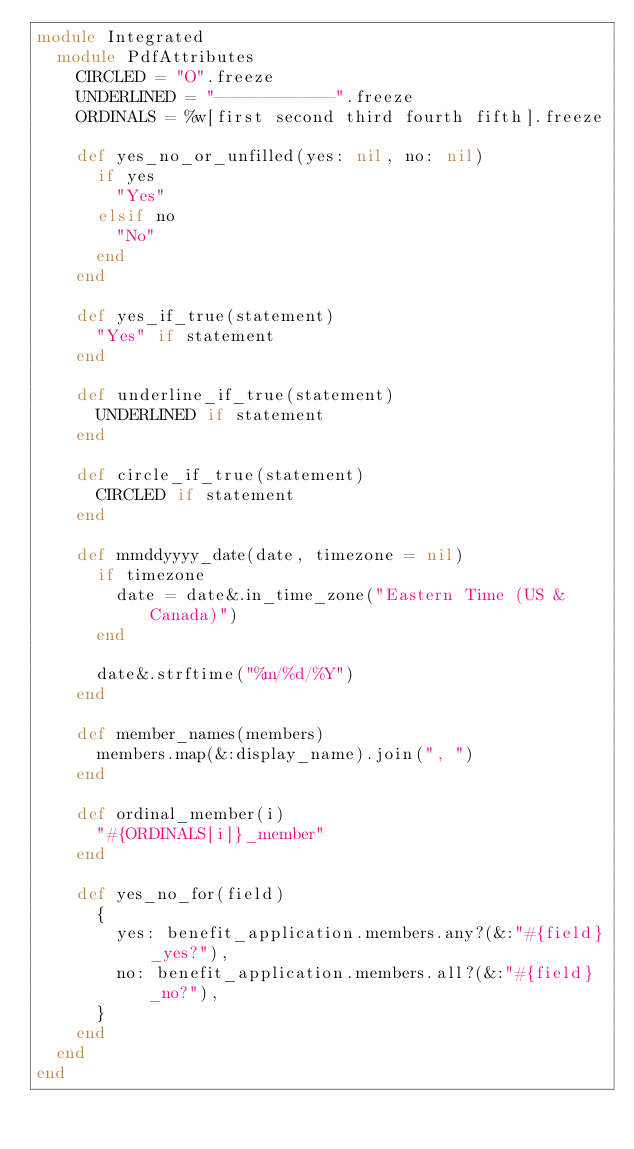<code> <loc_0><loc_0><loc_500><loc_500><_Ruby_>module Integrated
  module PdfAttributes
    CIRCLED = "O".freeze
    UNDERLINED = "------------".freeze
    ORDINALS = %w[first second third fourth fifth].freeze

    def yes_no_or_unfilled(yes: nil, no: nil)
      if yes
        "Yes"
      elsif no
        "No"
      end
    end

    def yes_if_true(statement)
      "Yes" if statement
    end

    def underline_if_true(statement)
      UNDERLINED if statement
    end

    def circle_if_true(statement)
      CIRCLED if statement
    end

    def mmddyyyy_date(date, timezone = nil)
      if timezone
        date = date&.in_time_zone("Eastern Time (US & Canada)")
      end

      date&.strftime("%m/%d/%Y")
    end

    def member_names(members)
      members.map(&:display_name).join(", ")
    end

    def ordinal_member(i)
      "#{ORDINALS[i]}_member"
    end

    def yes_no_for(field)
      {
        yes: benefit_application.members.any?(&:"#{field}_yes?"),
        no: benefit_application.members.all?(&:"#{field}_no?"),
      }
    end
  end
end
</code> 